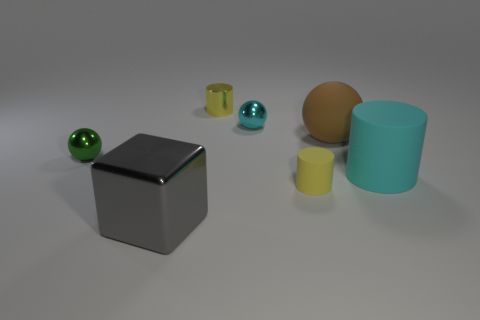What time of day does this image evoke for you? The scene doesn't imply a specific time of day, as the lighting is diffuse and lacks directional shadows. It evokes an indoor setting, possibly under artificial lighting, which is consistent at any time. 